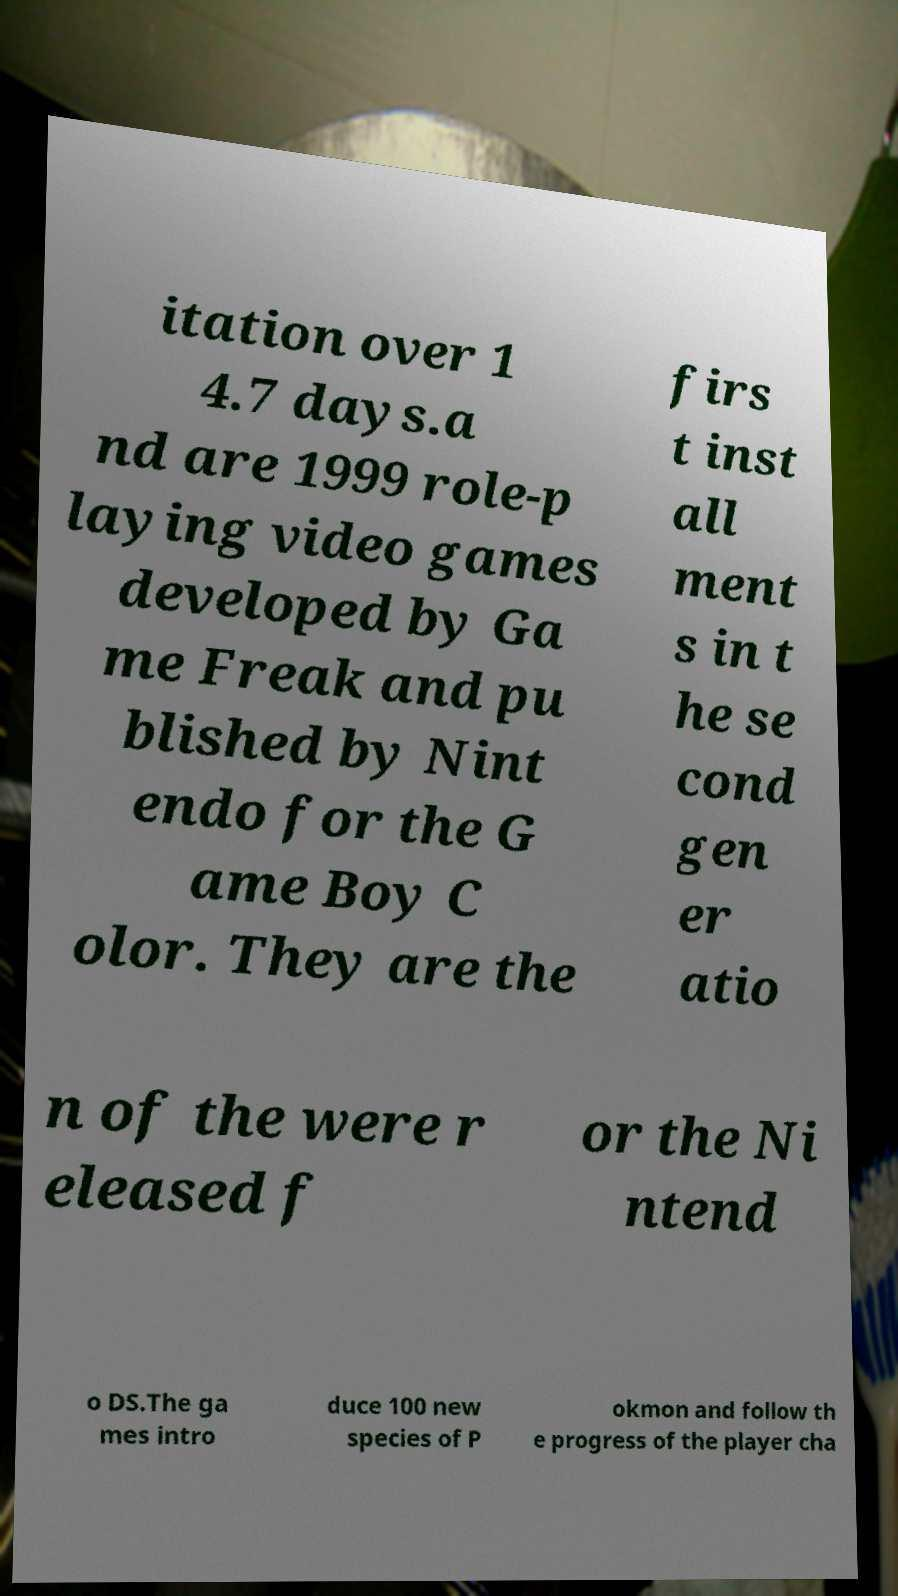Could you extract and type out the text from this image? itation over 1 4.7 days.a nd are 1999 role-p laying video games developed by Ga me Freak and pu blished by Nint endo for the G ame Boy C olor. They are the firs t inst all ment s in t he se cond gen er atio n of the were r eleased f or the Ni ntend o DS.The ga mes intro duce 100 new species of P okmon and follow th e progress of the player cha 